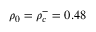Convert formula to latex. <formula><loc_0><loc_0><loc_500><loc_500>\rho _ { 0 } = \rho _ { c } ^ { - } = 0 . 4 8</formula> 